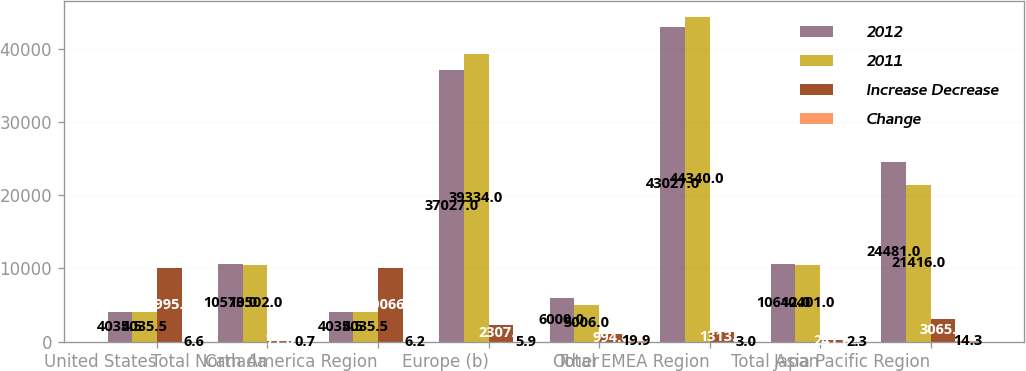<chart> <loc_0><loc_0><loc_500><loc_500><stacked_bar_chart><ecel><fcel>United States<fcel>Canada<fcel>Total North America Region<fcel>Europe (b)<fcel>Other<fcel>Total EMEA Region<fcel>Japan<fcel>Total Asia Pacific Region<nl><fcel>2012<fcel>4035.5<fcel>10573<fcel>4035.5<fcel>37027<fcel>6000<fcel>43027<fcel>10642<fcel>24481<nl><fcel>2011<fcel>4035.5<fcel>10502<fcel>4035.5<fcel>39334<fcel>5006<fcel>44340<fcel>10401<fcel>21416<nl><fcel>Increase Decrease<fcel>9995<fcel>71<fcel>10066<fcel>2307<fcel>994<fcel>1313<fcel>241<fcel>3065<nl><fcel>Change<fcel>6.6<fcel>0.7<fcel>6.2<fcel>5.9<fcel>19.9<fcel>3<fcel>2.3<fcel>14.3<nl></chart> 